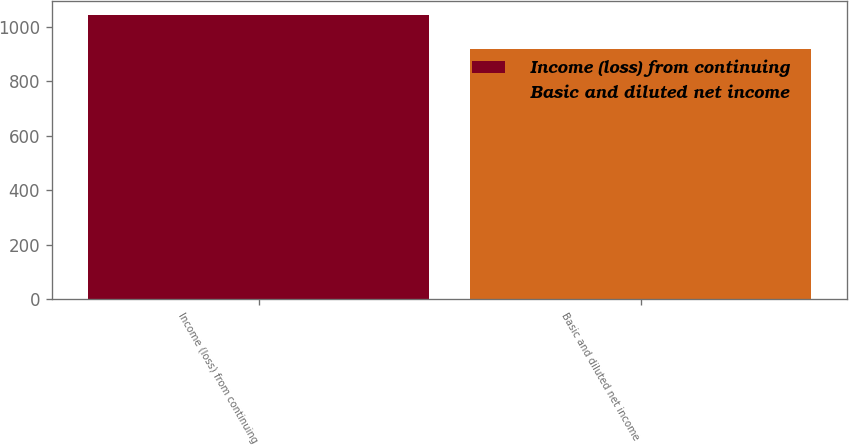Convert chart. <chart><loc_0><loc_0><loc_500><loc_500><bar_chart><fcel>Income (loss) from continuing<fcel>Basic and diluted net income<nl><fcel>1043.1<fcel>920<nl></chart> 